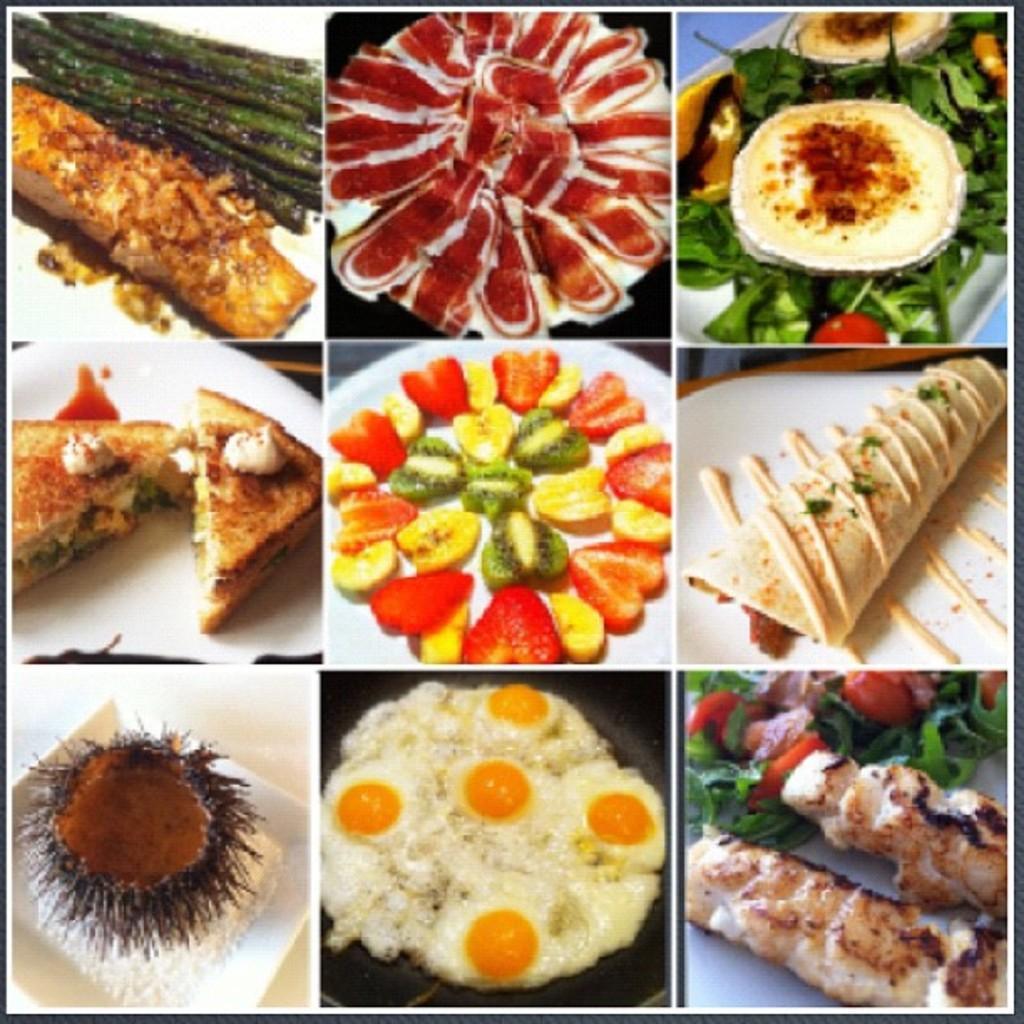How would you summarize this image in a sentence or two? This image contains a collage of photos of food items. Middle of the image there are few fruit slices on the plate. Beside there are few breads stuffed with food which are on the plate. Right top there is some leafy vegetable and some food on the plate. 